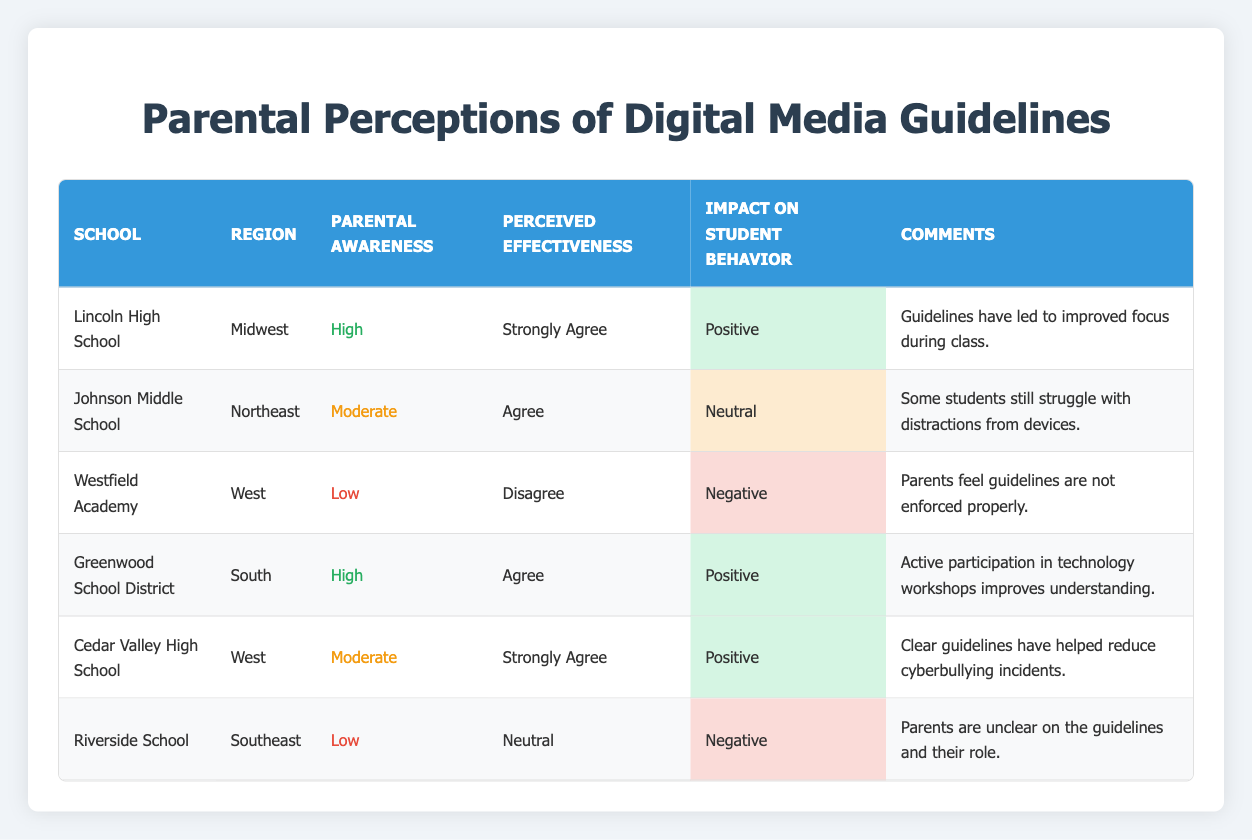What is the perceived effectiveness of the guidelines at Lincoln High School? The table indicates that Lincoln High School has a "Perceived Effectiveness" rating of "Strongly Agree."
Answer: Strongly Agree Which school has a low parental awareness level but a negative impact on student behavior? In the table, Westfield Academy is listed with a "Parental Awareness Level" of "Low" and an "Impact on Student Behavior" as "Negative."
Answer: Westfield Academy How many schools perceive the guidelines as having a positive impact on student behavior? By reviewing the table, three schools—Lincoln High School, Greenwood School District, and Cedar Valley High School—are noted for having a "Positive" impact on student behavior.
Answer: Three schools Is it true that all schools with high parental awareness have a positive impact on student behavior? Examining the data, Lincoln High School and Greenwood School District both report a "Positive" impact, but this is not the case for Riverside School, which has "Low" awareness and a "Negative" impact. Thus, the statement is false.
Answer: No What is the average perceived effectiveness level across all schools based on the table provided? The perceived effectiveness ratings are: Strongly Agree (2), Agree (3), Neutral (2), and Disagree (1). For average calculation, viewing as ratings (4, 3, 2, 1) gives us: (2x4 + 3x3 + 2x2 + 1x1) = 8 + 9 + 4 + 1 = 22, divided by 8 (total schools) equals 2.75 or Neutral.
Answer: Neutral 